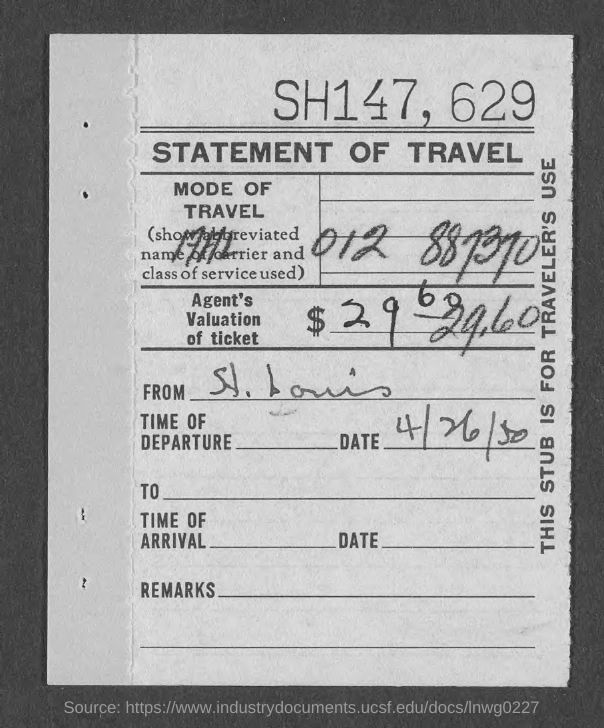What kind of statement is given here?
Give a very brief answer. Statement of Travel. What is the date of departure given in the statement?
Your answer should be compact. 4/26/50. 